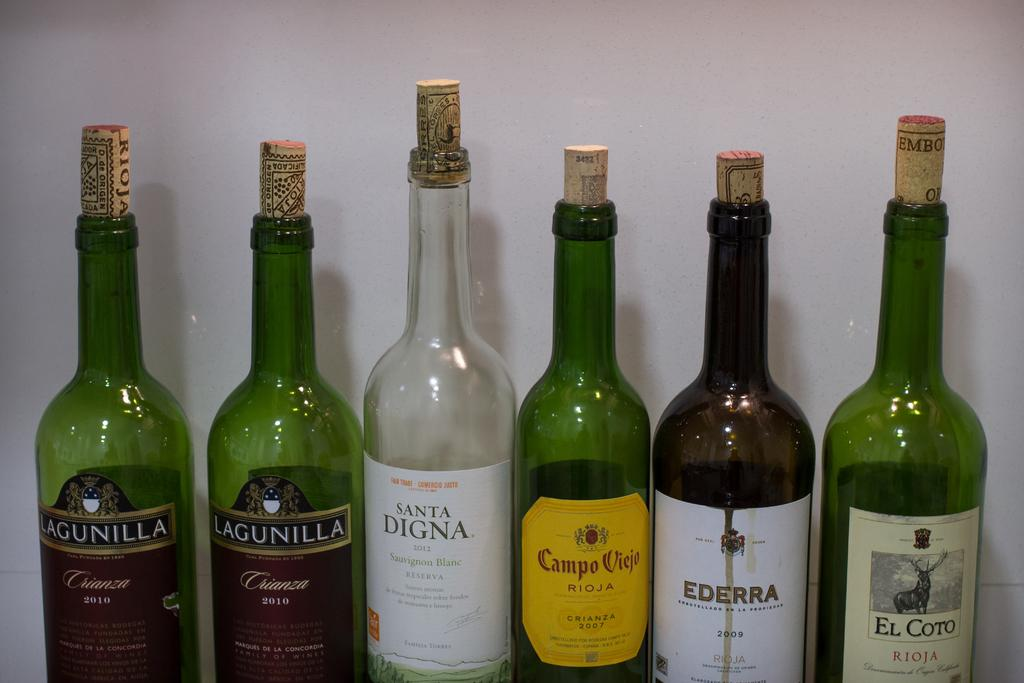<image>
Share a concise interpretation of the image provided. Six wine bottle with one of them named Santa Digna. 